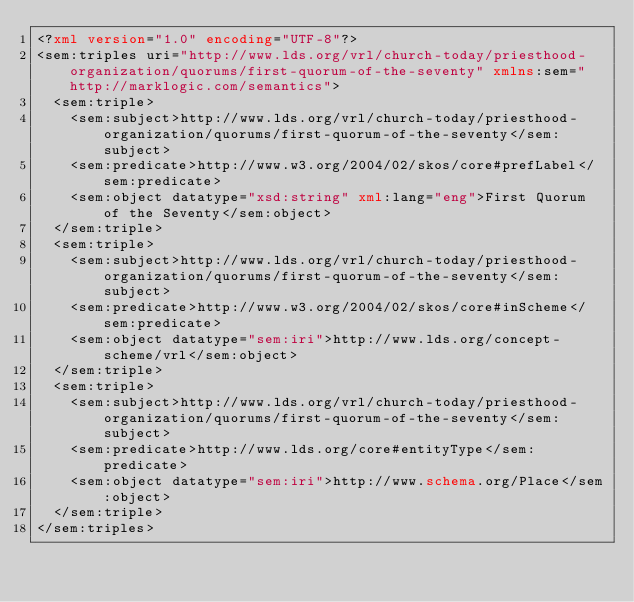Convert code to text. <code><loc_0><loc_0><loc_500><loc_500><_XML_><?xml version="1.0" encoding="UTF-8"?>
<sem:triples uri="http://www.lds.org/vrl/church-today/priesthood-organization/quorums/first-quorum-of-the-seventy" xmlns:sem="http://marklogic.com/semantics">
  <sem:triple>
    <sem:subject>http://www.lds.org/vrl/church-today/priesthood-organization/quorums/first-quorum-of-the-seventy</sem:subject>
    <sem:predicate>http://www.w3.org/2004/02/skos/core#prefLabel</sem:predicate>
    <sem:object datatype="xsd:string" xml:lang="eng">First Quorum of the Seventy</sem:object>
  </sem:triple>
  <sem:triple>
    <sem:subject>http://www.lds.org/vrl/church-today/priesthood-organization/quorums/first-quorum-of-the-seventy</sem:subject>
    <sem:predicate>http://www.w3.org/2004/02/skos/core#inScheme</sem:predicate>
    <sem:object datatype="sem:iri">http://www.lds.org/concept-scheme/vrl</sem:object>
  </sem:triple>
  <sem:triple>
    <sem:subject>http://www.lds.org/vrl/church-today/priesthood-organization/quorums/first-quorum-of-the-seventy</sem:subject>
    <sem:predicate>http://www.lds.org/core#entityType</sem:predicate>
    <sem:object datatype="sem:iri">http://www.schema.org/Place</sem:object>
  </sem:triple>
</sem:triples>
</code> 